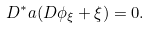<formula> <loc_0><loc_0><loc_500><loc_500>D ^ { * } a ( D \phi _ { \xi } + \xi ) = 0 .</formula> 